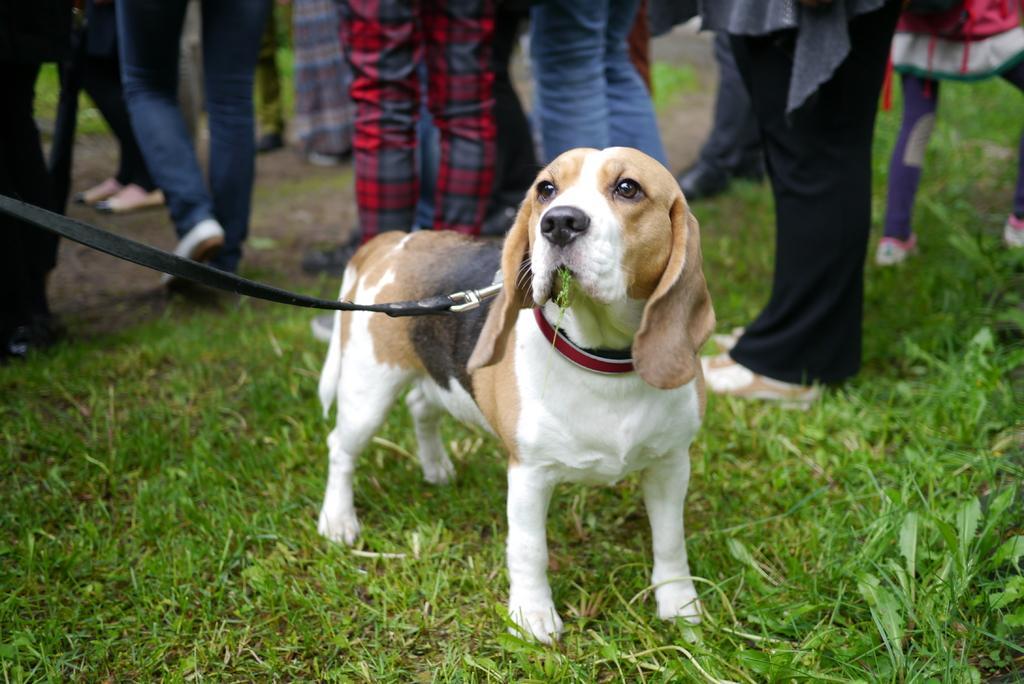Could you give a brief overview of what you see in this image? In this picture I can see a dog with a dog belt. I can see grass, leaves, and in the background there are group of people. 